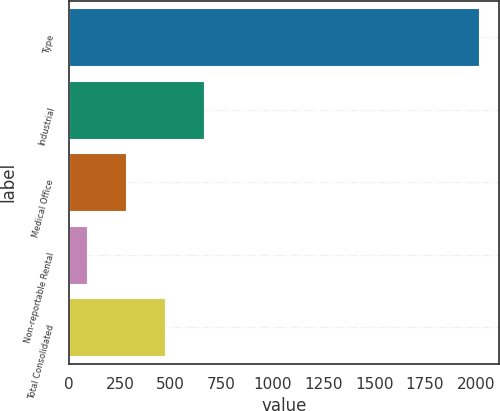Convert chart. <chart><loc_0><loc_0><loc_500><loc_500><bar_chart><fcel>Type<fcel>Industrial<fcel>Medical Office<fcel>Non-reportable Rental<fcel>Total Consolidated<nl><fcel>2015<fcel>664.91<fcel>279.17<fcel>86.3<fcel>472.04<nl></chart> 